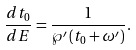Convert formula to latex. <formula><loc_0><loc_0><loc_500><loc_500>\frac { d t _ { 0 } } { d E } = \frac { 1 } { \wp ^ { \prime } \left ( t _ { 0 } + \omega ^ { \prime } \right ) } .</formula> 